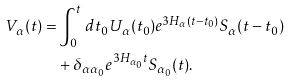Convert formula to latex. <formula><loc_0><loc_0><loc_500><loc_500>V _ { \alpha } ( t ) = & \int _ { 0 } ^ { t } \, d t _ { 0 } U _ { \alpha } ( t _ { 0 } ) e ^ { 3 H _ { \alpha } ( t - t _ { 0 } ) } S _ { \alpha } ( t - t _ { 0 } ) \\ & + \delta _ { \alpha \alpha _ { 0 } } e ^ { 3 H _ { \alpha _ { 0 } } t } S _ { \alpha _ { 0 } } ( t ) .</formula> 